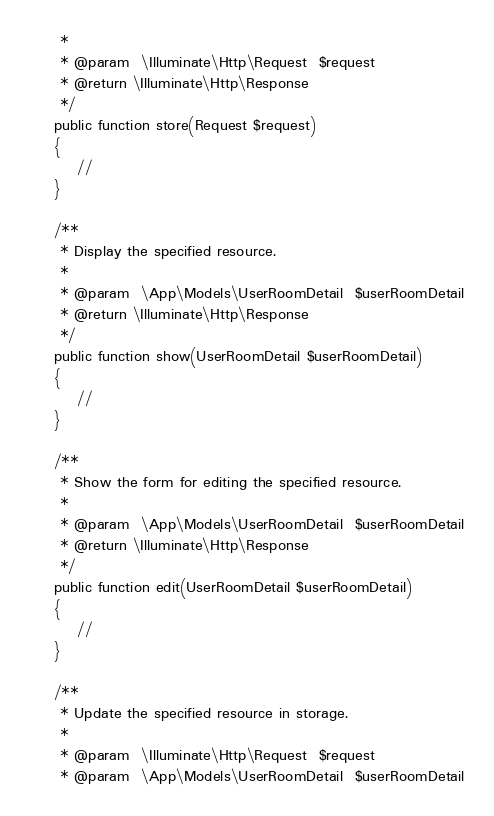<code> <loc_0><loc_0><loc_500><loc_500><_PHP_>     *
     * @param  \Illuminate\Http\Request  $request
     * @return \Illuminate\Http\Response
     */
    public function store(Request $request)
    {
        //
    }

    /**
     * Display the specified resource.
     *
     * @param  \App\Models\UserRoomDetail  $userRoomDetail
     * @return \Illuminate\Http\Response
     */
    public function show(UserRoomDetail $userRoomDetail)
    {
        //
    }

    /**
     * Show the form for editing the specified resource.
     *
     * @param  \App\Models\UserRoomDetail  $userRoomDetail
     * @return \Illuminate\Http\Response
     */
    public function edit(UserRoomDetail $userRoomDetail)
    {
        //
    }

    /**
     * Update the specified resource in storage.
     *
     * @param  \Illuminate\Http\Request  $request
     * @param  \App\Models\UserRoomDetail  $userRoomDetail</code> 